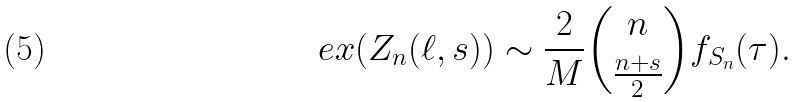Convert formula to latex. <formula><loc_0><loc_0><loc_500><loc_500>\ e x ( Z _ { n } ( \ell , s ) ) \sim \frac { 2 } { M } \binom { n } { \frac { n + s } { 2 } } f _ { S _ { n } } ( \tau ) .</formula> 